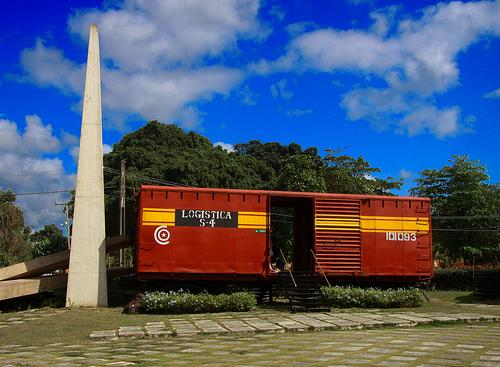Express in a sentence the main subject of the image and its most striking aspect. The central subject is a red and yellow boxcar museum, distinguished by the numbers 101093 and a star logo on its side. Briefly illustrate the primary object in the picture and its distinct attribute. The main object is a boxcar museum, painted red and yellow, with the number 101093 and a star logo. Point out the main object in the image and one key aspect that makes it visually interesting. The focal point is a red and yellow train car turned into a museum, prominently displaying the number 101093 and a star logo. Provide an overview of the image, focusing on the dominant object. The image showcases a red and yellow boxcar museum, surrounded by a pointy structure, stairs, and a grassy pathway. Depict the main focal point in the image, mentioning its unique features. The image features a red and yellow train car transformed into a museum, with the number 101093, a star logo, and Logistica S4 inscribed on it. Identify the key subject of the image and what surrounds it. The main subject is a boxcar-turned-museum; the surroundings include a pointy cement-colored structure, a stairway, and a grass-covered stone path. Describe the main object in the image along with its prominent color. The central focus is a red and yellow boxcar with the numbers 101093 and a star logo on the side. Mention the primary object within the image and its most prominent characteristic. The red and yellow train car is the central object, displaying the numbers 101093 and a star logo on its exterior. In a sentence, pinpoint the central object within the image and its most outstanding element. The red and yellow boxcar museum draws attention, particularly due to the "101093" and star logo markings on its side. Concisely describe the image and the key object it focuses on. The image centers on a vibrant red and yellow train car, converted into a museum, featuring unique markings. 